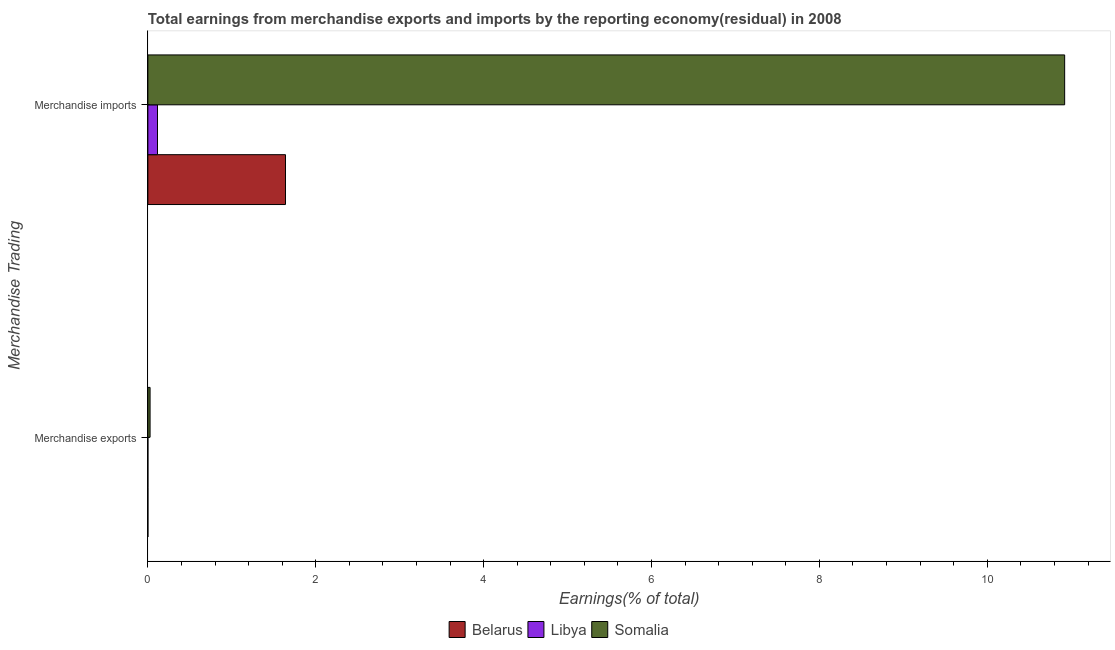How many different coloured bars are there?
Keep it short and to the point. 3. How many groups of bars are there?
Give a very brief answer. 2. How many bars are there on the 2nd tick from the bottom?
Offer a terse response. 3. What is the earnings from merchandise imports in Libya?
Keep it short and to the point. 0.11. Across all countries, what is the maximum earnings from merchandise exports?
Ensure brevity in your answer.  0.03. Across all countries, what is the minimum earnings from merchandise imports?
Keep it short and to the point. 0.11. In which country was the earnings from merchandise imports maximum?
Your answer should be compact. Somalia. In which country was the earnings from merchandise imports minimum?
Provide a succinct answer. Libya. What is the total earnings from merchandise exports in the graph?
Provide a succinct answer. 0.03. What is the difference between the earnings from merchandise imports in Somalia and that in Libya?
Your response must be concise. 10.81. What is the difference between the earnings from merchandise imports in Somalia and the earnings from merchandise exports in Belarus?
Your answer should be compact. 10.92. What is the average earnings from merchandise imports per country?
Give a very brief answer. 4.23. What is the difference between the earnings from merchandise exports and earnings from merchandise imports in Libya?
Provide a succinct answer. -0.11. In how many countries, is the earnings from merchandise imports greater than 6.8 %?
Your answer should be compact. 1. What is the ratio of the earnings from merchandise imports in Somalia to that in Belarus?
Offer a terse response. 6.66. In how many countries, is the earnings from merchandise imports greater than the average earnings from merchandise imports taken over all countries?
Give a very brief answer. 1. What does the 3rd bar from the top in Merchandise imports represents?
Provide a short and direct response. Belarus. What does the 3rd bar from the bottom in Merchandise exports represents?
Your answer should be very brief. Somalia. How many bars are there?
Provide a succinct answer. 6. Are all the bars in the graph horizontal?
Keep it short and to the point. Yes. What is the difference between two consecutive major ticks on the X-axis?
Make the answer very short. 2. Does the graph contain any zero values?
Keep it short and to the point. No. Does the graph contain grids?
Ensure brevity in your answer.  No. What is the title of the graph?
Provide a succinct answer. Total earnings from merchandise exports and imports by the reporting economy(residual) in 2008. Does "Other small states" appear as one of the legend labels in the graph?
Make the answer very short. No. What is the label or title of the X-axis?
Your answer should be compact. Earnings(% of total). What is the label or title of the Y-axis?
Your answer should be very brief. Merchandise Trading. What is the Earnings(% of total) in Belarus in Merchandise exports?
Your answer should be very brief. 0. What is the Earnings(% of total) of Libya in Merchandise exports?
Give a very brief answer. 1.38991464235186e-9. What is the Earnings(% of total) in Somalia in Merchandise exports?
Give a very brief answer. 0.03. What is the Earnings(% of total) of Belarus in Merchandise imports?
Make the answer very short. 1.64. What is the Earnings(% of total) in Libya in Merchandise imports?
Make the answer very short. 0.11. What is the Earnings(% of total) in Somalia in Merchandise imports?
Keep it short and to the point. 10.92. Across all Merchandise Trading, what is the maximum Earnings(% of total) of Belarus?
Make the answer very short. 1.64. Across all Merchandise Trading, what is the maximum Earnings(% of total) of Libya?
Offer a terse response. 0.11. Across all Merchandise Trading, what is the maximum Earnings(% of total) in Somalia?
Make the answer very short. 10.92. Across all Merchandise Trading, what is the minimum Earnings(% of total) in Belarus?
Offer a very short reply. 0. Across all Merchandise Trading, what is the minimum Earnings(% of total) of Libya?
Your response must be concise. 1.38991464235186e-9. Across all Merchandise Trading, what is the minimum Earnings(% of total) of Somalia?
Provide a succinct answer. 0.03. What is the total Earnings(% of total) of Belarus in the graph?
Ensure brevity in your answer.  1.64. What is the total Earnings(% of total) in Libya in the graph?
Your answer should be very brief. 0.11. What is the total Earnings(% of total) of Somalia in the graph?
Offer a terse response. 10.95. What is the difference between the Earnings(% of total) in Belarus in Merchandise exports and that in Merchandise imports?
Your answer should be very brief. -1.64. What is the difference between the Earnings(% of total) of Libya in Merchandise exports and that in Merchandise imports?
Offer a very short reply. -0.11. What is the difference between the Earnings(% of total) in Somalia in Merchandise exports and that in Merchandise imports?
Keep it short and to the point. -10.9. What is the difference between the Earnings(% of total) of Belarus in Merchandise exports and the Earnings(% of total) of Libya in Merchandise imports?
Ensure brevity in your answer.  -0.11. What is the difference between the Earnings(% of total) of Belarus in Merchandise exports and the Earnings(% of total) of Somalia in Merchandise imports?
Provide a succinct answer. -10.92. What is the difference between the Earnings(% of total) of Libya in Merchandise exports and the Earnings(% of total) of Somalia in Merchandise imports?
Your answer should be very brief. -10.92. What is the average Earnings(% of total) of Belarus per Merchandise Trading?
Give a very brief answer. 0.82. What is the average Earnings(% of total) in Libya per Merchandise Trading?
Your response must be concise. 0.06. What is the average Earnings(% of total) of Somalia per Merchandise Trading?
Give a very brief answer. 5.47. What is the difference between the Earnings(% of total) in Belarus and Earnings(% of total) in Libya in Merchandise exports?
Ensure brevity in your answer.  0. What is the difference between the Earnings(% of total) of Belarus and Earnings(% of total) of Somalia in Merchandise exports?
Offer a terse response. -0.03. What is the difference between the Earnings(% of total) of Libya and Earnings(% of total) of Somalia in Merchandise exports?
Provide a succinct answer. -0.03. What is the difference between the Earnings(% of total) of Belarus and Earnings(% of total) of Libya in Merchandise imports?
Give a very brief answer. 1.52. What is the difference between the Earnings(% of total) of Belarus and Earnings(% of total) of Somalia in Merchandise imports?
Offer a terse response. -9.28. What is the difference between the Earnings(% of total) in Libya and Earnings(% of total) in Somalia in Merchandise imports?
Keep it short and to the point. -10.81. What is the ratio of the Earnings(% of total) of Belarus in Merchandise exports to that in Merchandise imports?
Your answer should be compact. 0. What is the ratio of the Earnings(% of total) in Somalia in Merchandise exports to that in Merchandise imports?
Your response must be concise. 0. What is the difference between the highest and the second highest Earnings(% of total) of Belarus?
Offer a terse response. 1.64. What is the difference between the highest and the second highest Earnings(% of total) in Libya?
Offer a very short reply. 0.11. What is the difference between the highest and the second highest Earnings(% of total) of Somalia?
Provide a succinct answer. 10.9. What is the difference between the highest and the lowest Earnings(% of total) of Belarus?
Offer a very short reply. 1.64. What is the difference between the highest and the lowest Earnings(% of total) of Libya?
Your answer should be very brief. 0.11. What is the difference between the highest and the lowest Earnings(% of total) of Somalia?
Your answer should be compact. 10.9. 